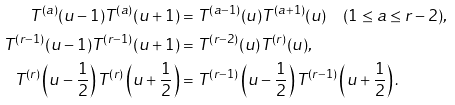Convert formula to latex. <formula><loc_0><loc_0><loc_500><loc_500>T ^ { ( a ) } ( u - 1 ) T ^ { ( a ) } ( u + 1 ) & = T ^ { ( a - 1 ) } ( u ) T ^ { ( a + 1 ) } ( u ) \quad ( 1 \leq a \leq r - 2 ) , \\ T ^ { ( r - 1 ) } ( u - 1 ) T ^ { ( r - 1 ) } ( u + 1 ) & = T ^ { ( r - 2 ) } ( u ) T ^ { ( r ) } ( u ) , \\ T ^ { ( r ) } \left ( u - \frac { 1 } { 2 } \right ) T ^ { ( r ) } \left ( u + \frac { 1 } { 2 } \right ) & = T ^ { ( r - 1 ) } \left ( u - \frac { 1 } { 2 } \right ) T ^ { ( r - 1 ) } \left ( u + \frac { 1 } { 2 } \right ) .</formula> 